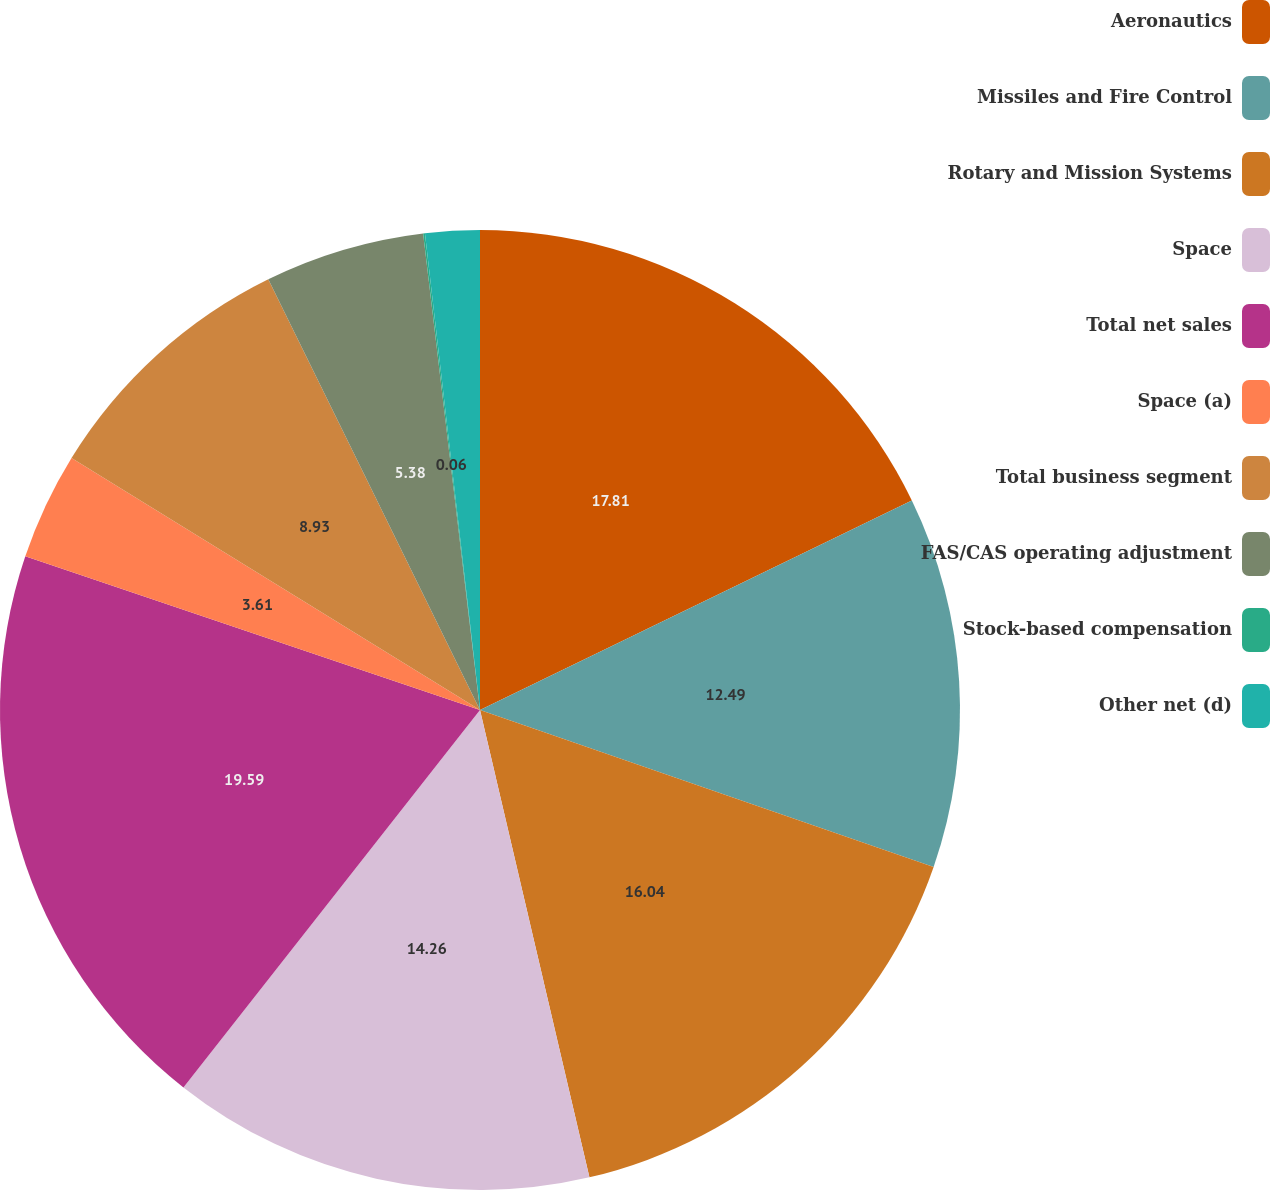Convert chart to OTSL. <chart><loc_0><loc_0><loc_500><loc_500><pie_chart><fcel>Aeronautics<fcel>Missiles and Fire Control<fcel>Rotary and Mission Systems<fcel>Space<fcel>Total net sales<fcel>Space (a)<fcel>Total business segment<fcel>FAS/CAS operating adjustment<fcel>Stock-based compensation<fcel>Other net (d)<nl><fcel>17.81%<fcel>12.49%<fcel>16.04%<fcel>14.26%<fcel>19.59%<fcel>3.61%<fcel>8.93%<fcel>5.38%<fcel>0.06%<fcel>1.83%<nl></chart> 